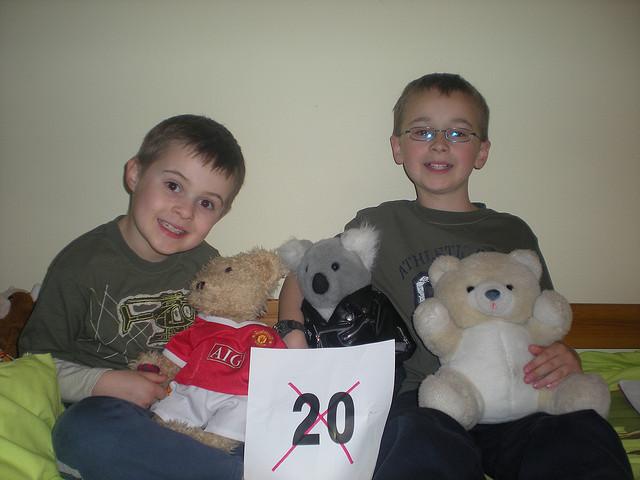What is the bear wearing?
Answer briefly. Shirt. Is there a cartoon mustache in the picture?
Write a very short answer. No. What is crossed out?
Be succinct. 20. What is on the boy?
Write a very short answer. Teddy bear. What color is the little boy's shirt?
Concise answer only. Green. How many bears are being held?
Short answer required. 3. Is this bear in the shade?
Quick response, please. No. How many people are in the picture?
Short answer required. 2. What numbers are shown in the background?
Answer briefly. 20. How old is the boy?
Be succinct. 6. Are the boys brothers?
Be succinct. Yes. What type of fabric are the bears made of?
Give a very brief answer. Cotton. 